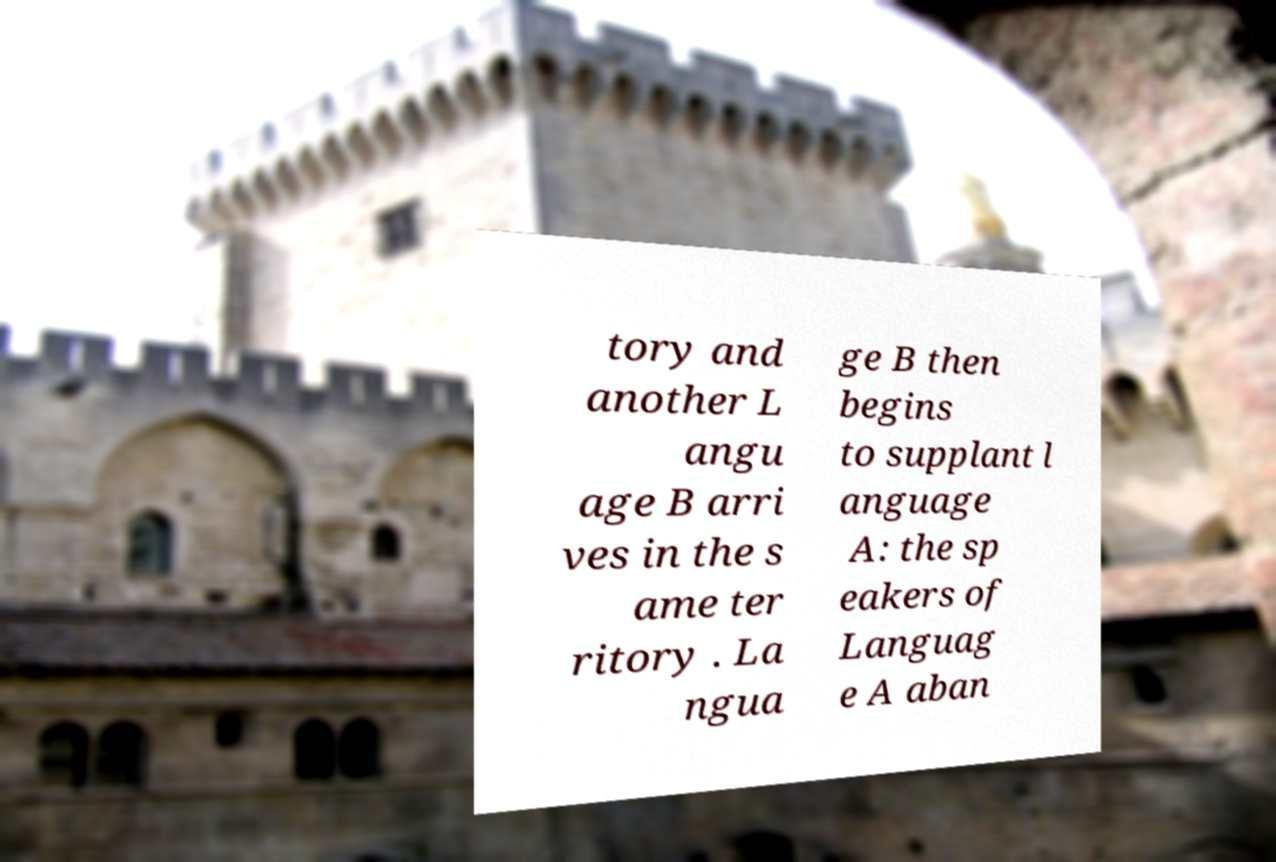Could you assist in decoding the text presented in this image and type it out clearly? tory and another L angu age B arri ves in the s ame ter ritory . La ngua ge B then begins to supplant l anguage A: the sp eakers of Languag e A aban 